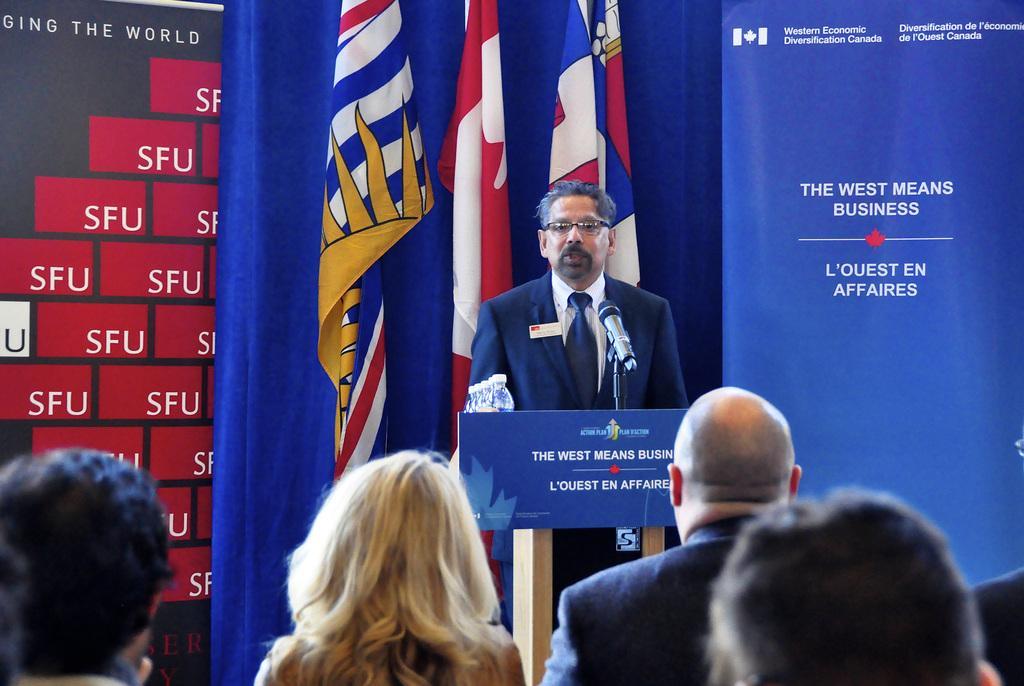Please provide a concise description of this image. This image is taken indoors. In the background there are two banners with text on them. There are a few flags. In the middle of the image a man is standing and there is a podium with a mic and a board with a text on it. There are a few bottles on the podium. At the bottom of the image there are a few people. 